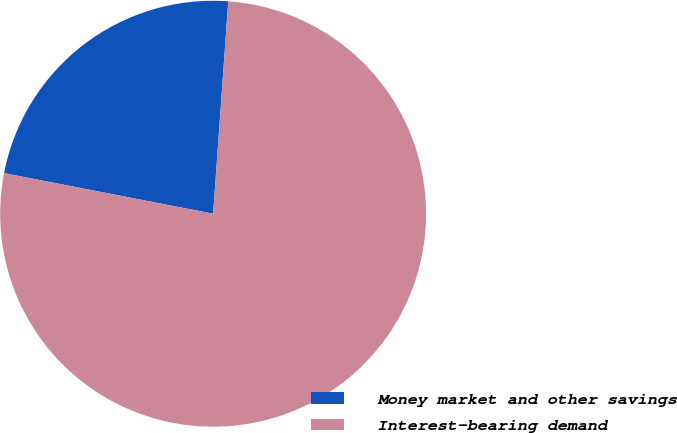Convert chart. <chart><loc_0><loc_0><loc_500><loc_500><pie_chart><fcel>Money market and other savings<fcel>Interest-bearing demand<nl><fcel>23.08%<fcel>76.92%<nl></chart> 